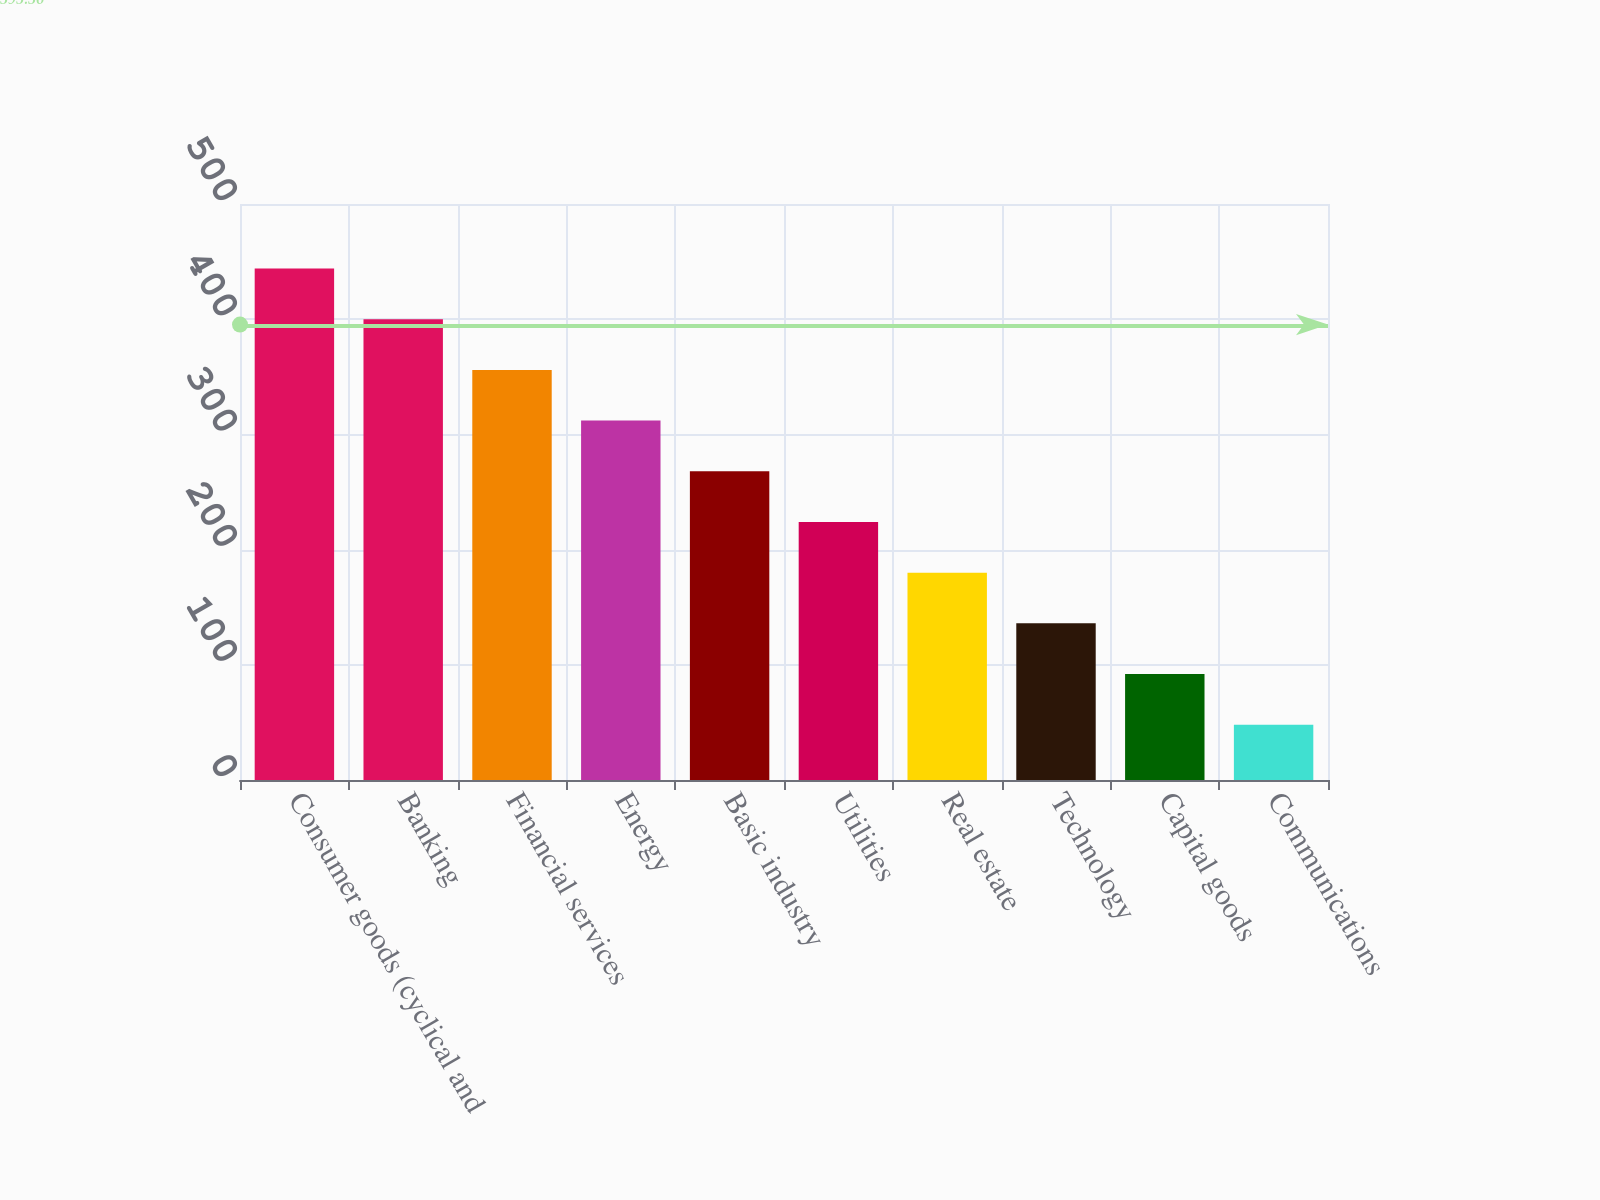Convert chart. <chart><loc_0><loc_0><loc_500><loc_500><bar_chart><fcel>Consumer goods (cyclical and<fcel>Banking<fcel>Financial services<fcel>Energy<fcel>Basic industry<fcel>Utilities<fcel>Real estate<fcel>Technology<fcel>Capital goods<fcel>Communications<nl><fcel>444<fcel>400<fcel>356<fcel>312<fcel>268<fcel>224<fcel>180<fcel>136<fcel>92<fcel>48<nl></chart> 